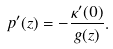<formula> <loc_0><loc_0><loc_500><loc_500>p ^ { \prime } ( z ) = - \frac { \kappa ^ { \prime } ( 0 ) } { g ( z ) } .</formula> 